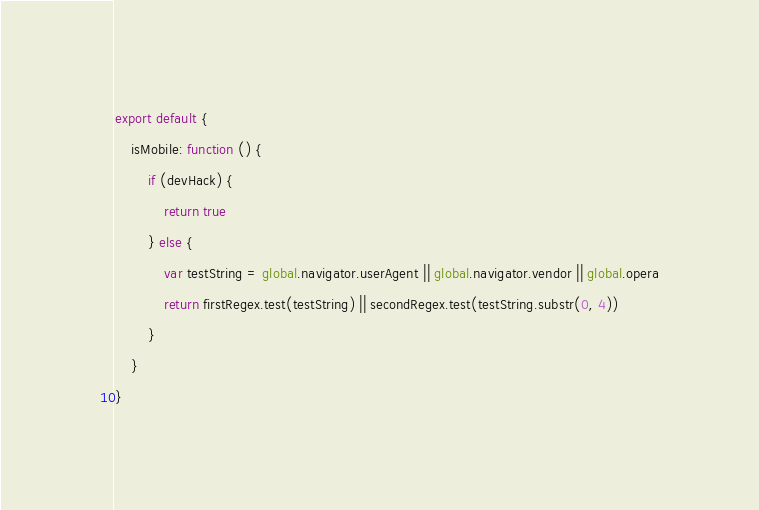Convert code to text. <code><loc_0><loc_0><loc_500><loc_500><_JavaScript_>export default {
	isMobile: function () {
		if (devHack) {
			return true
		} else {
			var testString = global.navigator.userAgent || global.navigator.vendor || global.opera
			return firstRegex.test(testString) || secondRegex.test(testString.substr(0, 4))
		}
	}
}
</code> 